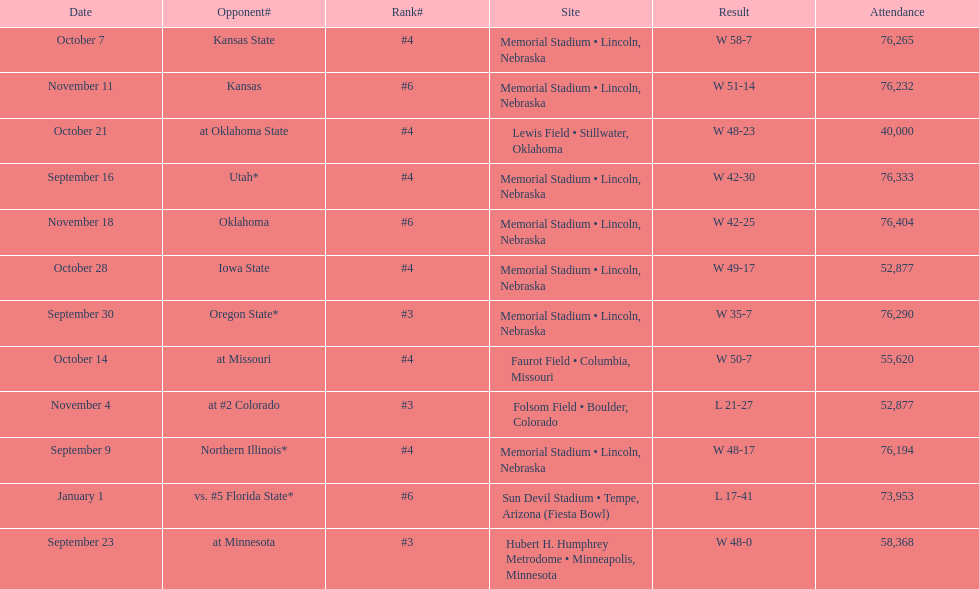When is the first game? September 9. 